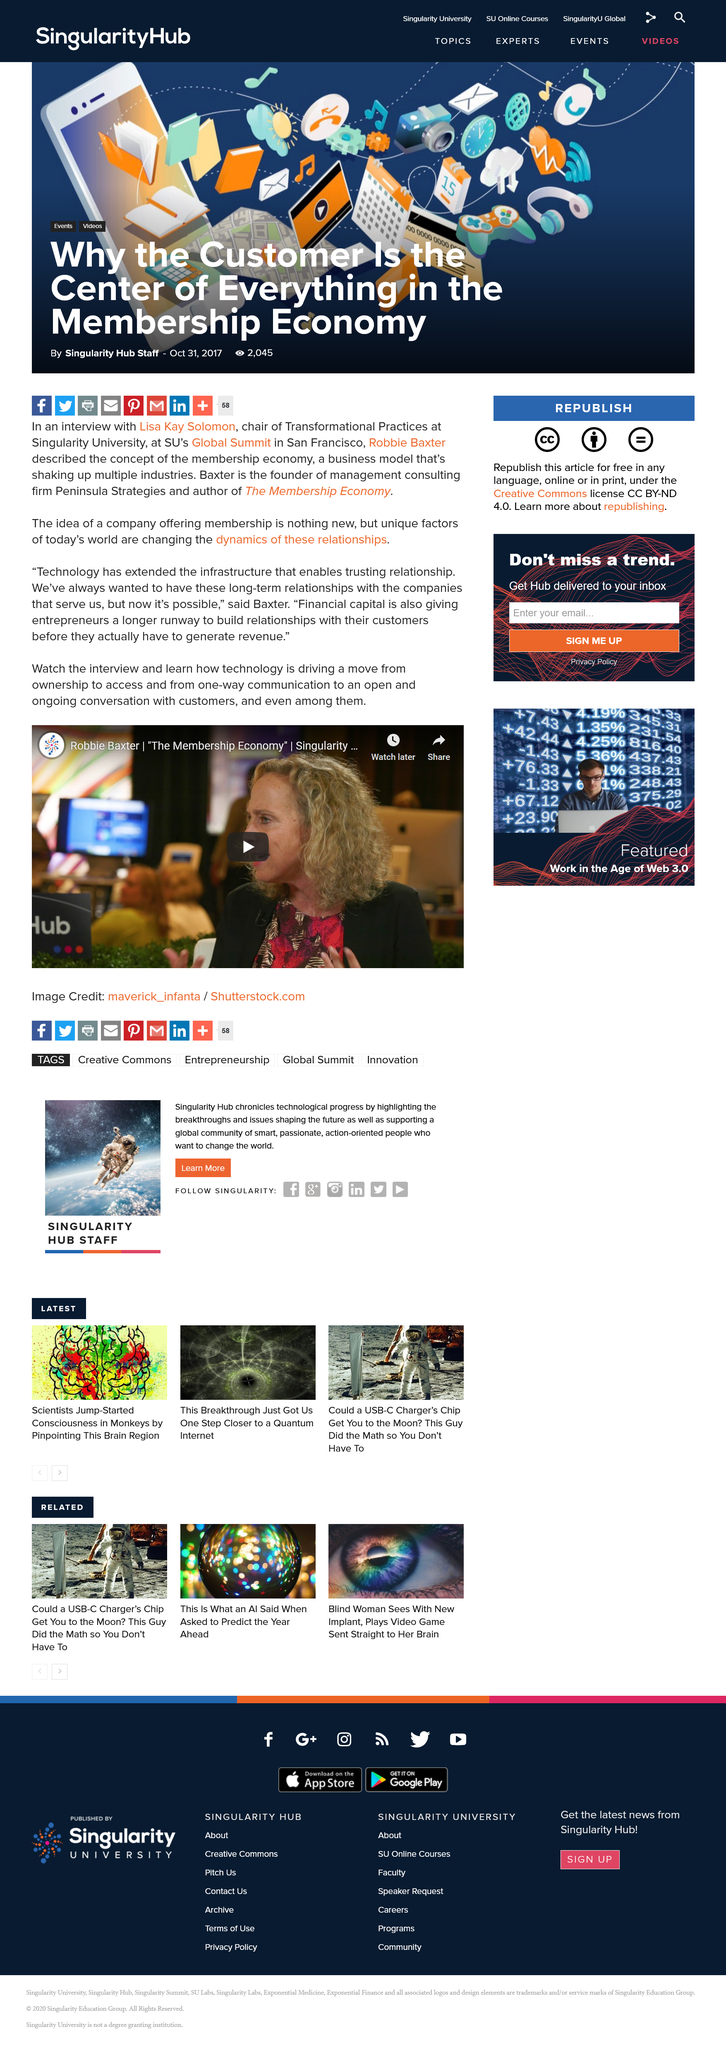Specify some key components in this picture. The unique factors that are currently shaping the dynamics of membership offerings include changes in consumer preferences and demographics, advancements in technology, and the rise of new business models. These factors are challenging traditional definitions of membership and are leading to a shift in the way organizations approach and engage with their members. It is not the case that a company offering membership is newly established. Financial capital giving entrepreneurs a longer runway to build relationships with their customers before generating revenue, is essential for their success. 